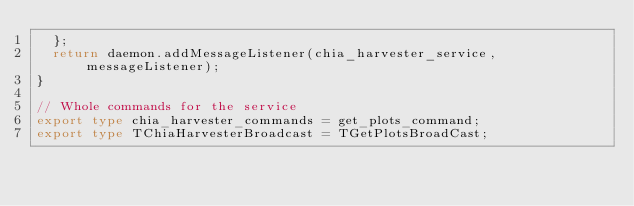<code> <loc_0><loc_0><loc_500><loc_500><_TypeScript_>  };
  return daemon.addMessageListener(chia_harvester_service, messageListener);
}

// Whole commands for the service
export type chia_harvester_commands = get_plots_command;
export type TChiaHarvesterBroadcast = TGetPlotsBroadCast;</code> 